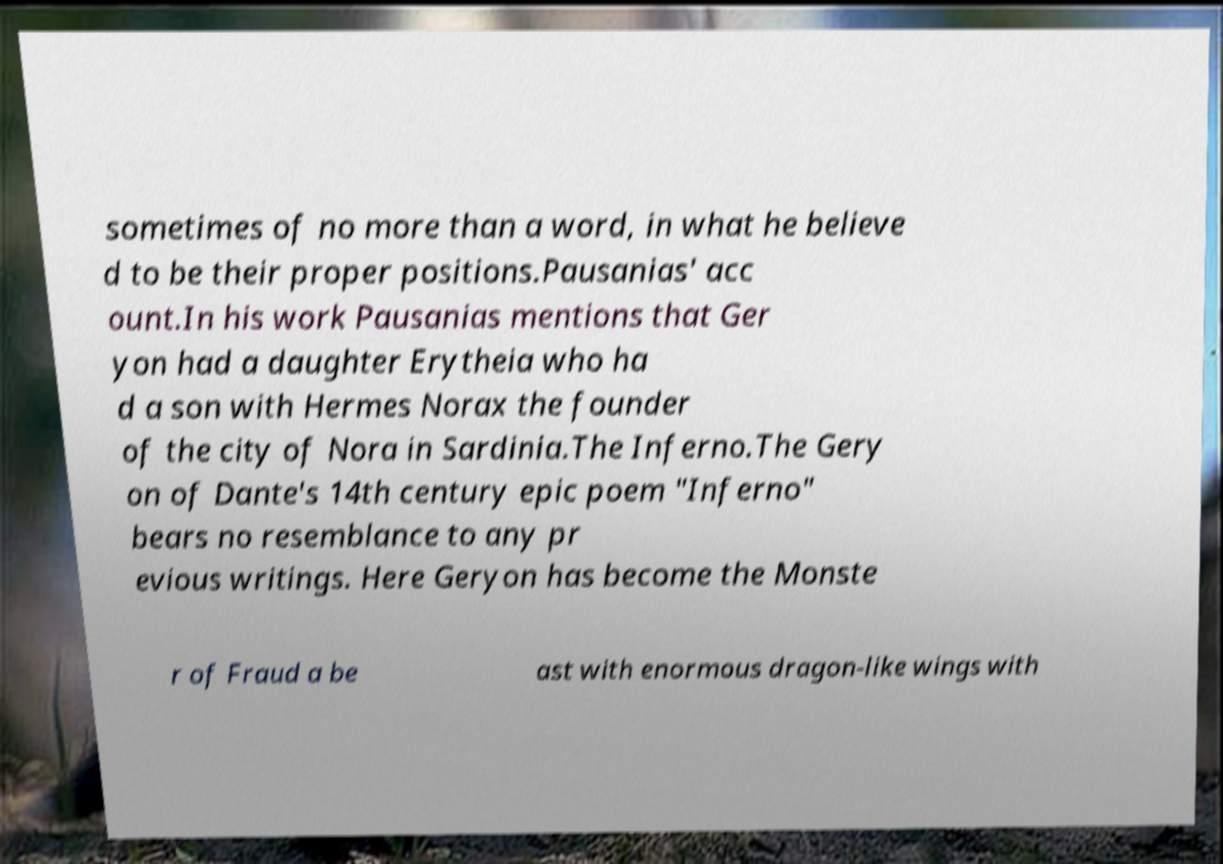I need the written content from this picture converted into text. Can you do that? sometimes of no more than a word, in what he believe d to be their proper positions.Pausanias' acc ount.In his work Pausanias mentions that Ger yon had a daughter Erytheia who ha d a son with Hermes Norax the founder of the city of Nora in Sardinia.The Inferno.The Gery on of Dante's 14th century epic poem "Inferno" bears no resemblance to any pr evious writings. Here Geryon has become the Monste r of Fraud a be ast with enormous dragon-like wings with 